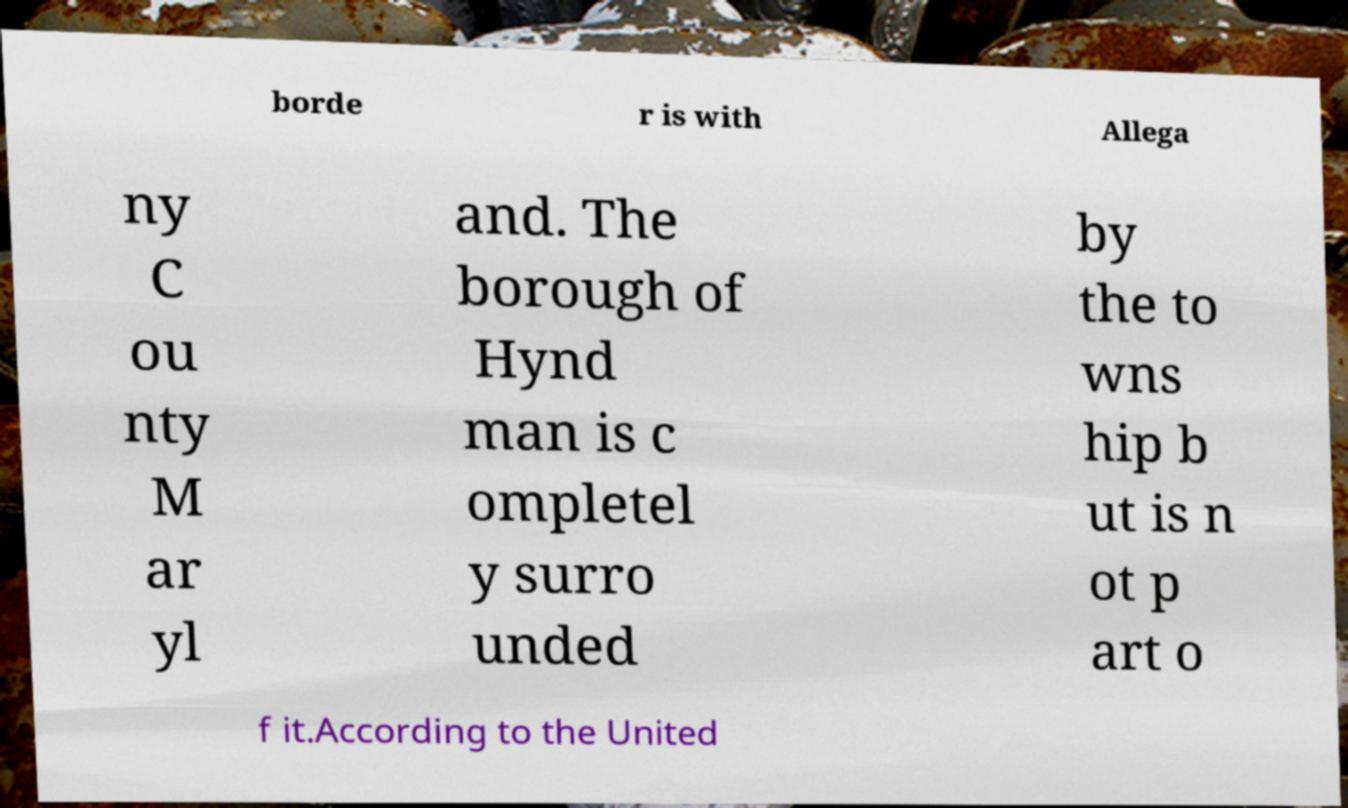I need the written content from this picture converted into text. Can you do that? borde r is with Allega ny C ou nty M ar yl and. The borough of Hynd man is c ompletel y surro unded by the to wns hip b ut is n ot p art o f it.According to the United 